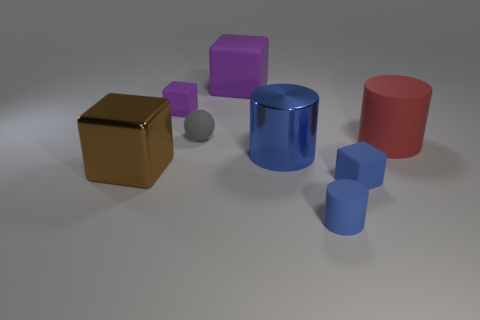What shape is the tiny thing that is the same color as the large rubber block?
Ensure brevity in your answer.  Cube. There is a cylinder in front of the tiny rubber cube to the right of the purple object right of the ball; what is its material?
Provide a succinct answer. Rubber. What material is the small blue object that is to the left of the small matte cube that is in front of the sphere?
Ensure brevity in your answer.  Rubber. Do the blue cylinder that is behind the brown thing and the matte cube to the left of the gray matte sphere have the same size?
Your answer should be very brief. No. Are there any other things that are made of the same material as the big purple block?
Ensure brevity in your answer.  Yes. What number of small objects are either brown shiny blocks or yellow metal objects?
Keep it short and to the point. 0. What number of objects are either gray rubber objects to the right of the large brown object or gray matte spheres?
Provide a succinct answer. 1. Does the large metal block have the same color as the big matte cylinder?
Give a very brief answer. No. How many other things are there of the same shape as the small purple thing?
Your answer should be compact. 3. How many gray things are either matte balls or big rubber cylinders?
Ensure brevity in your answer.  1. 